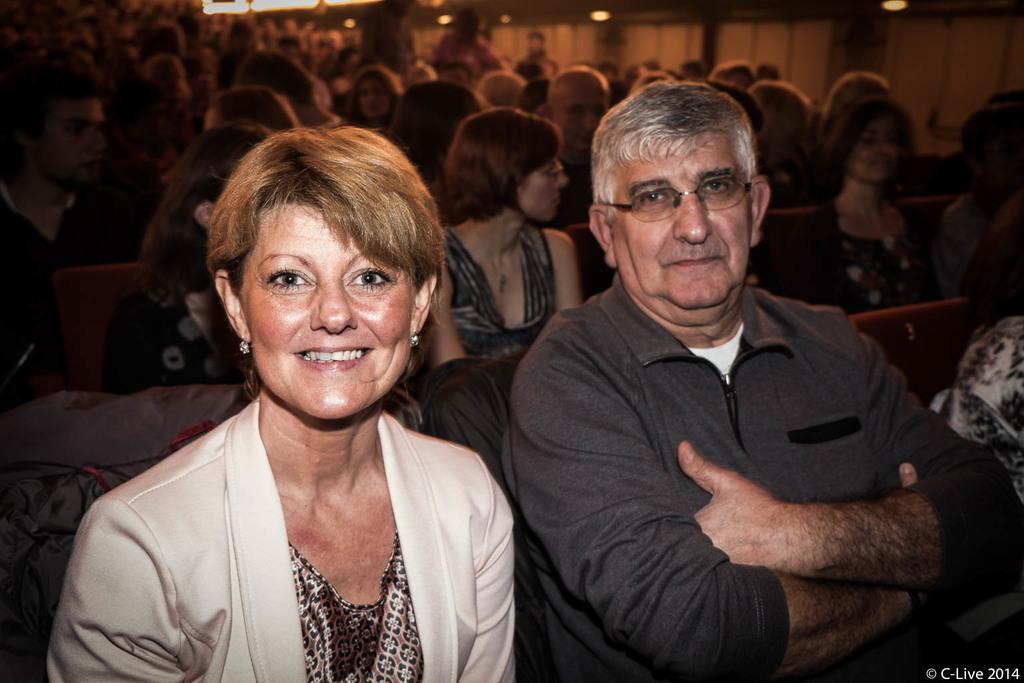How would you summarize this image in a sentence or two? In this image I can see group of people. There are chairs and also there are lights. 